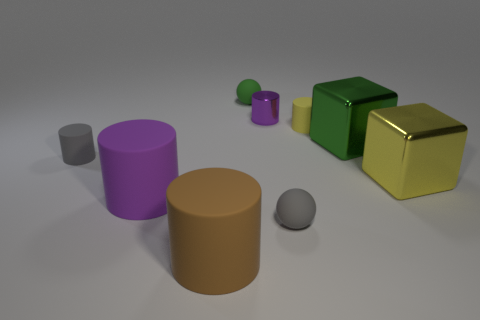There is a cylinder that is left of the gray rubber ball and on the right side of the large brown matte cylinder; what material is it?
Give a very brief answer. Metal. There is a purple matte cylinder that is behind the object that is in front of the matte ball in front of the green shiny thing; how big is it?
Your answer should be very brief. Large. There is a yellow rubber thing; is it the same shape as the brown thing to the right of the purple rubber thing?
Your answer should be compact. Yes. What number of tiny matte cylinders are to the right of the gray cylinder and left of the purple metallic cylinder?
Give a very brief answer. 0. What number of brown objects are either large matte things or rubber cylinders?
Offer a very short reply. 1. Is the color of the tiny matte cylinder on the right side of the green sphere the same as the small rubber cylinder on the left side of the brown cylinder?
Ensure brevity in your answer.  No. What is the color of the sphere right of the small sphere on the left side of the tiny sphere that is in front of the tiny purple object?
Ensure brevity in your answer.  Gray. There is a small yellow thing on the right side of the large purple cylinder; are there any matte cylinders behind it?
Give a very brief answer. No. Do the large metal object in front of the gray matte cylinder and the small purple metallic object have the same shape?
Ensure brevity in your answer.  No. Are there any other things that are the same shape as the small green rubber object?
Give a very brief answer. Yes. 